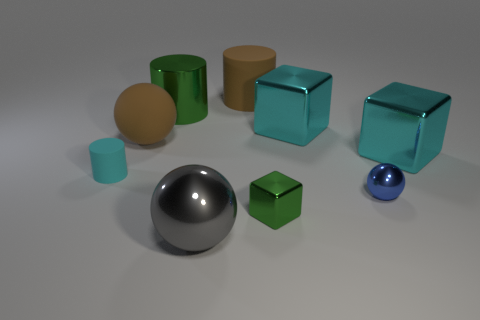How many small metal things are the same color as the big rubber cylinder?
Provide a succinct answer. 0. There is a large cyan metal block that is to the left of the big metallic thing to the right of the tiny blue ball; are there any spheres to the left of it?
Keep it short and to the point. Yes. There is a large thing that is made of the same material as the brown cylinder; what shape is it?
Provide a succinct answer. Sphere. Are there more tiny balls than large spheres?
Give a very brief answer. No. There is a small rubber thing; does it have the same shape as the brown matte thing to the right of the green cylinder?
Provide a succinct answer. Yes. What material is the big brown cylinder?
Your response must be concise. Rubber. What color is the large metallic cube behind the big brown thing left of the rubber cylinder that is on the right side of the gray sphere?
Offer a very short reply. Cyan. What material is the green object that is the same shape as the cyan matte object?
Your answer should be compact. Metal. What number of metallic spheres are the same size as the gray metal object?
Your response must be concise. 0. What number of cyan objects are there?
Your answer should be very brief. 3. 